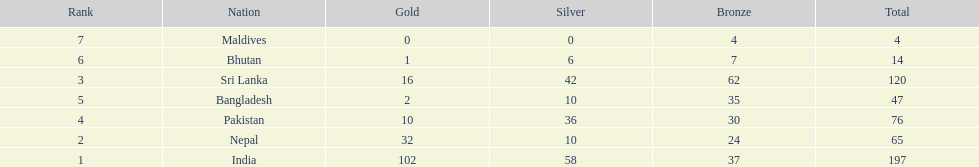What is the difference in total number of medals between india and nepal? 132. 